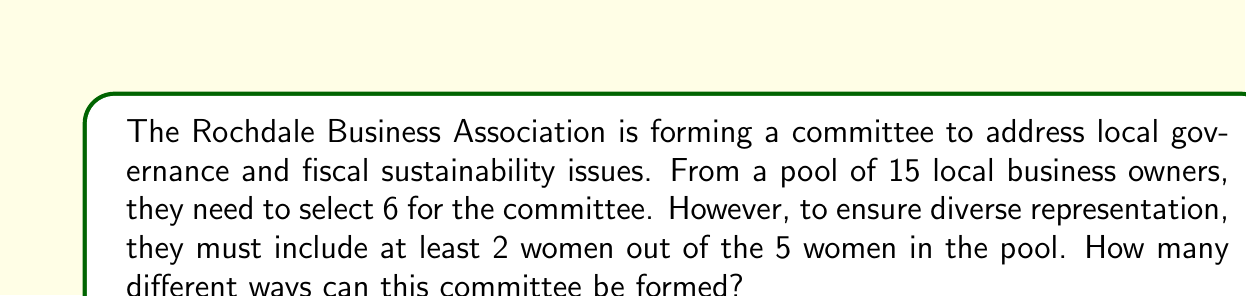Can you solve this math problem? Let's approach this step-by-step:

1) First, we need to consider the total number of women and men in the pool:
   - Total business owners: 15
   - Women: 5
   - Men: 15 - 5 = 10

2) We need to select at least 2 women, so let's consider the cases:
   Case 1: 2 women and 4 men
   Case 2: 3 women and 3 men
   Case 3: 4 women and 2 men
   Case 4: 5 women and 1 man

3) Let's calculate each case:

   Case 1: $\binom{5}{2} \times \binom{10}{4}$
   Case 2: $\binom{5}{3} \times \binom{10}{3}$
   Case 3: $\binom{5}{4} \times \binom{10}{2}$
   Case 4: $\binom{5}{5} \times \binom{10}{1}$

4) Now, let's compute:
   Case 1: $10 \times 210 = 2100$
   Case 2: $10 \times 120 = 1200$
   Case 3: $5 \times 45 = 225$
   Case 4: $1 \times 10 = 10$

5) The total number of ways is the sum of all cases:
   $2100 + 1200 + 225 + 10 = 3535$

Therefore, there are 3535 different ways to form the committee.
Answer: 3535 